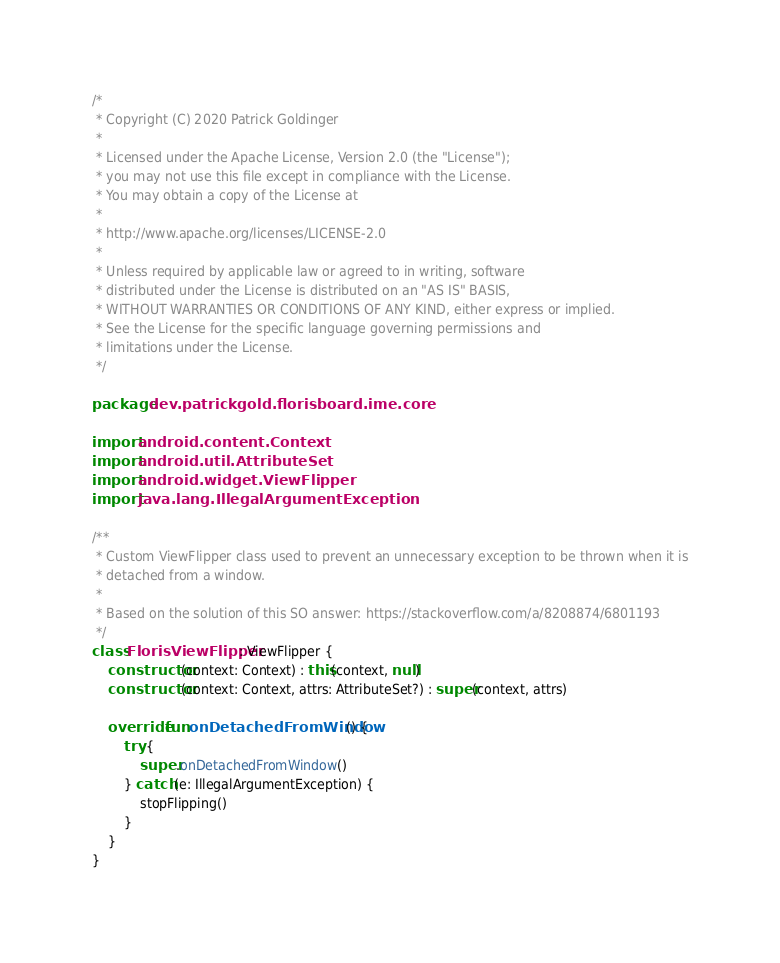<code> <loc_0><loc_0><loc_500><loc_500><_Kotlin_>/*
 * Copyright (C) 2020 Patrick Goldinger
 *
 * Licensed under the Apache License, Version 2.0 (the "License");
 * you may not use this file except in compliance with the License.
 * You may obtain a copy of the License at
 *
 * http://www.apache.org/licenses/LICENSE-2.0
 *
 * Unless required by applicable law or agreed to in writing, software
 * distributed under the License is distributed on an "AS IS" BASIS,
 * WITHOUT WARRANTIES OR CONDITIONS OF ANY KIND, either express or implied.
 * See the License for the specific language governing permissions and
 * limitations under the License.
 */

package dev.patrickgold.florisboard.ime.core

import android.content.Context
import android.util.AttributeSet
import android.widget.ViewFlipper
import java.lang.IllegalArgumentException

/**
 * Custom ViewFlipper class used to prevent an unnecessary exception to be thrown when it is
 * detached from a window.
 *
 * Based on the solution of this SO answer: https://stackoverflow.com/a/8208874/6801193
 */
class FlorisViewFlipper : ViewFlipper {
    constructor(context: Context) : this(context, null)
    constructor(context: Context, attrs: AttributeSet?) : super(context, attrs)

    override fun onDetachedFromWindow() {
        try {
            super.onDetachedFromWindow()
        } catch (e: IllegalArgumentException) {
            stopFlipping()
        }
    }
}
</code> 